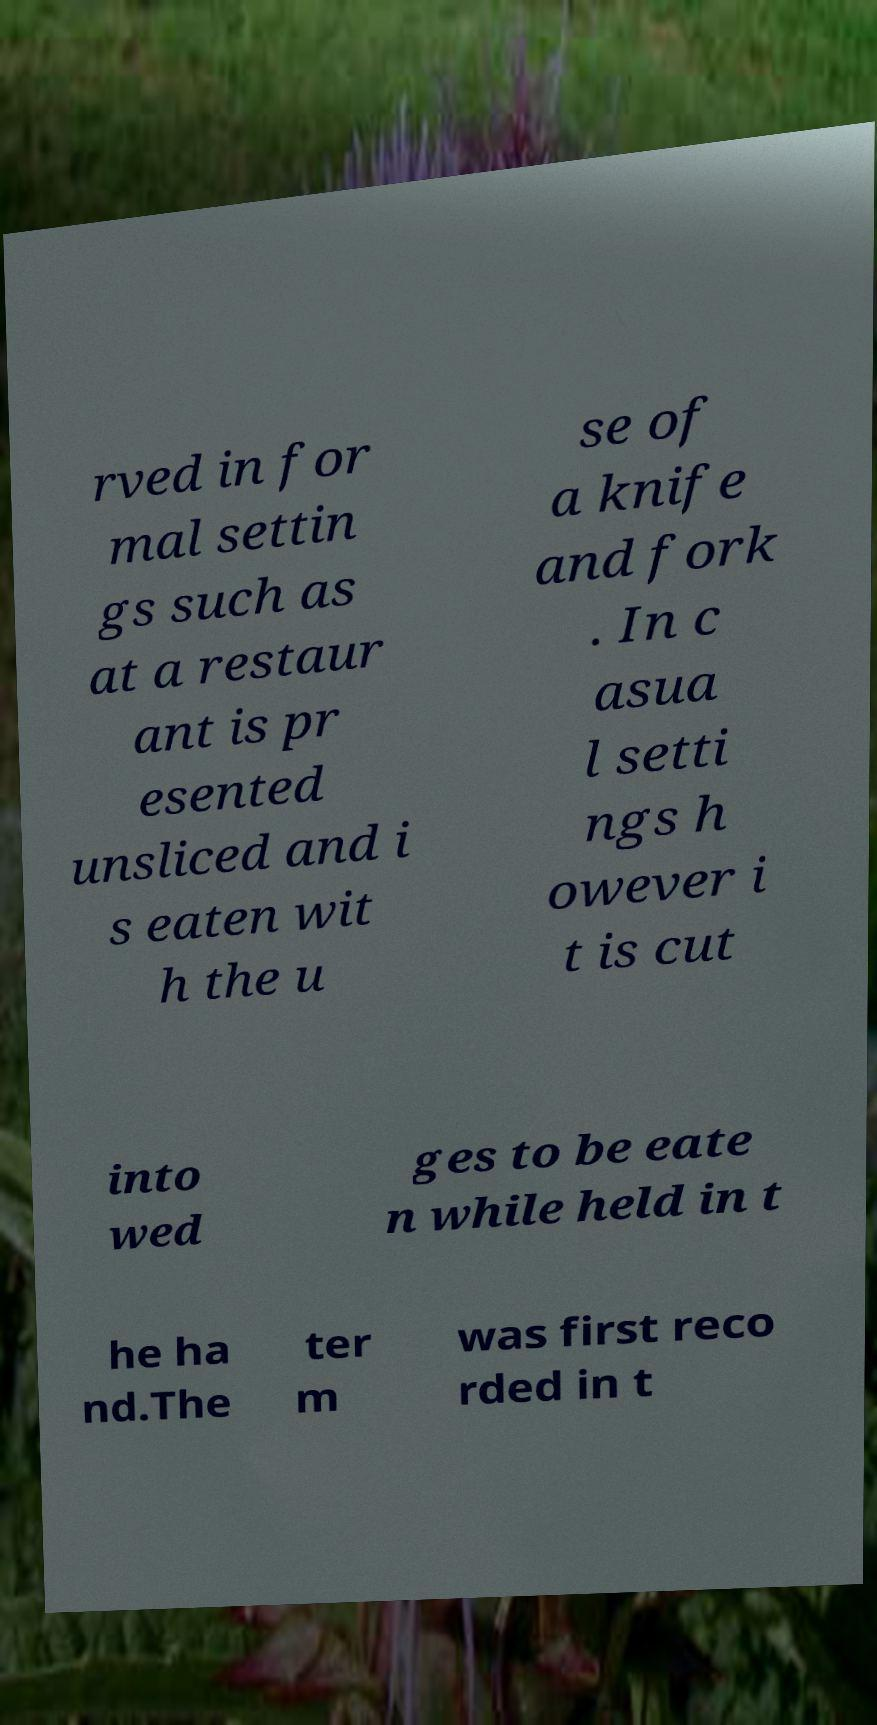For documentation purposes, I need the text within this image transcribed. Could you provide that? rved in for mal settin gs such as at a restaur ant is pr esented unsliced and i s eaten wit h the u se of a knife and fork . In c asua l setti ngs h owever i t is cut into wed ges to be eate n while held in t he ha nd.The ter m was first reco rded in t 